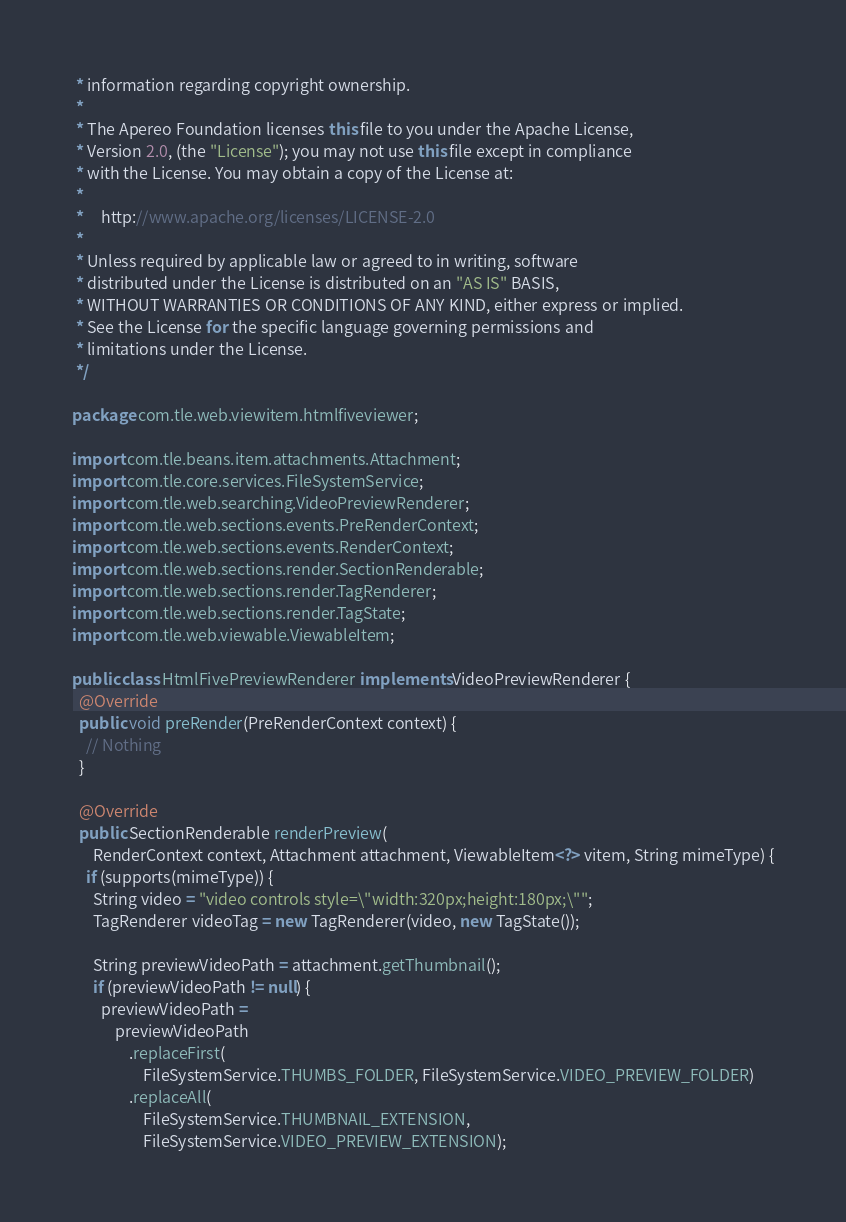<code> <loc_0><loc_0><loc_500><loc_500><_Java_> * information regarding copyright ownership.
 *
 * The Apereo Foundation licenses this file to you under the Apache License,
 * Version 2.0, (the "License"); you may not use this file except in compliance
 * with the License. You may obtain a copy of the License at:
 *
 *     http://www.apache.org/licenses/LICENSE-2.0
 *
 * Unless required by applicable law or agreed to in writing, software
 * distributed under the License is distributed on an "AS IS" BASIS,
 * WITHOUT WARRANTIES OR CONDITIONS OF ANY KIND, either express or implied.
 * See the License for the specific language governing permissions and
 * limitations under the License.
 */

package com.tle.web.viewitem.htmlfiveviewer;

import com.tle.beans.item.attachments.Attachment;
import com.tle.core.services.FileSystemService;
import com.tle.web.searching.VideoPreviewRenderer;
import com.tle.web.sections.events.PreRenderContext;
import com.tle.web.sections.events.RenderContext;
import com.tle.web.sections.render.SectionRenderable;
import com.tle.web.sections.render.TagRenderer;
import com.tle.web.sections.render.TagState;
import com.tle.web.viewable.ViewableItem;

public class HtmlFivePreviewRenderer implements VideoPreviewRenderer {
  @Override
  public void preRender(PreRenderContext context) {
    // Nothing
  }

  @Override
  public SectionRenderable renderPreview(
      RenderContext context, Attachment attachment, ViewableItem<?> vitem, String mimeType) {
    if (supports(mimeType)) {
      String video = "video controls style=\"width:320px;height:180px;\"";
      TagRenderer videoTag = new TagRenderer(video, new TagState());

      String previewVideoPath = attachment.getThumbnail();
      if (previewVideoPath != null) {
        previewVideoPath =
            previewVideoPath
                .replaceFirst(
                    FileSystemService.THUMBS_FOLDER, FileSystemService.VIDEO_PREVIEW_FOLDER)
                .replaceAll(
                    FileSystemService.THUMBNAIL_EXTENSION,
                    FileSystemService.VIDEO_PREVIEW_EXTENSION);
</code> 